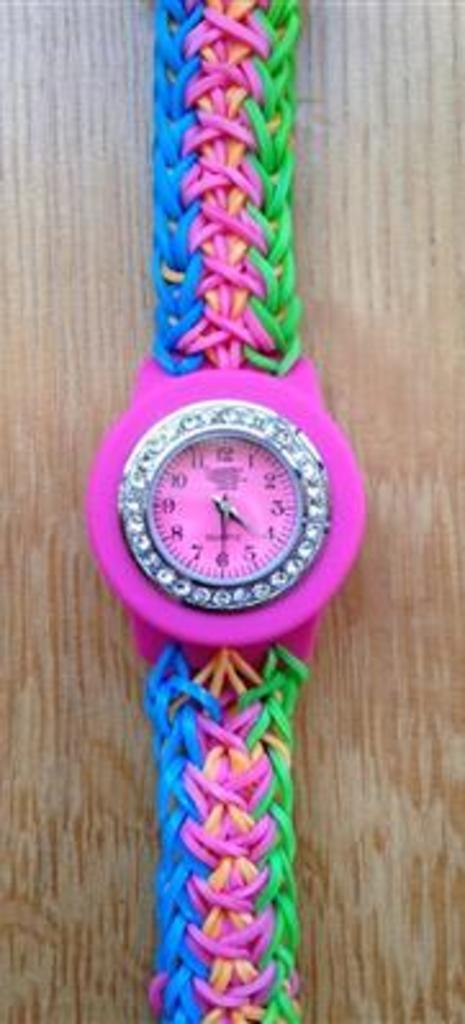<image>
Provide a brief description of the given image. A bright multicolored watch shows a time of 4:30. 